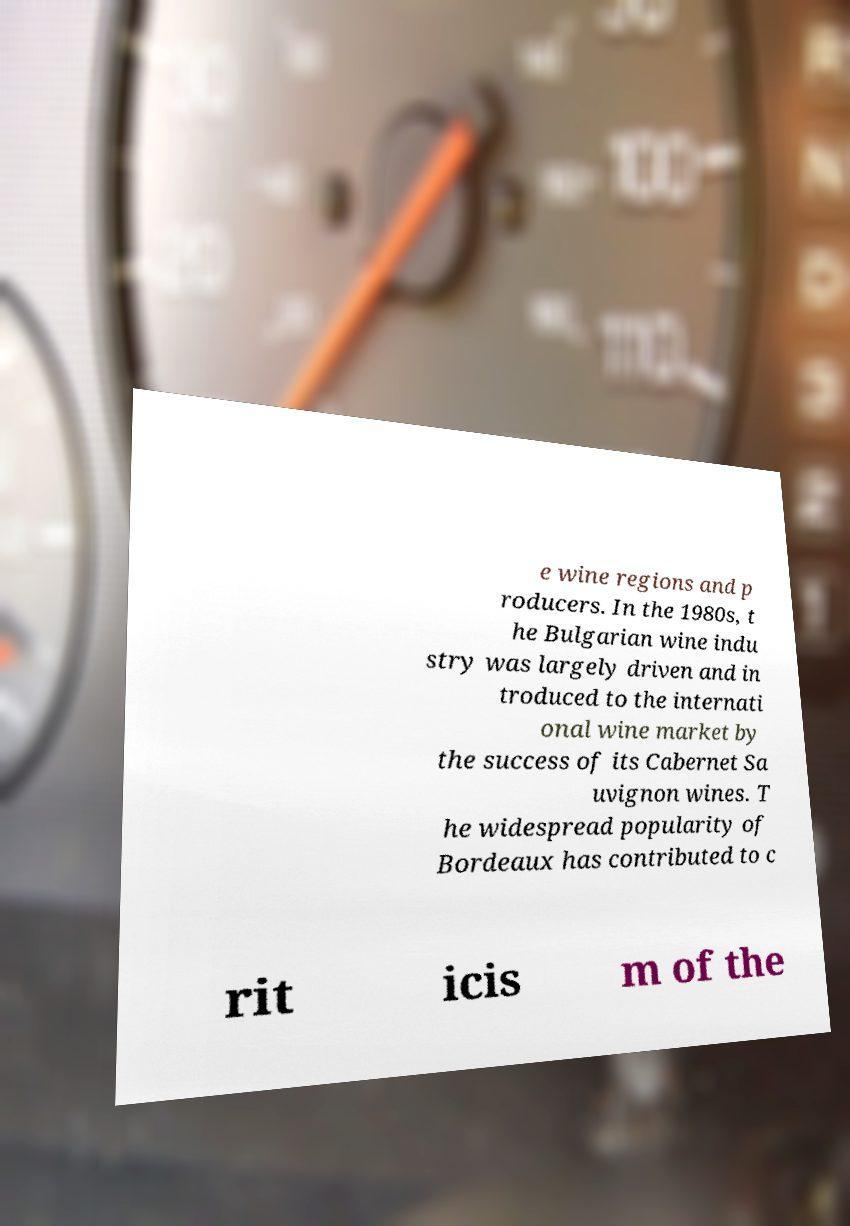Please read and relay the text visible in this image. What does it say? e wine regions and p roducers. In the 1980s, t he Bulgarian wine indu stry was largely driven and in troduced to the internati onal wine market by the success of its Cabernet Sa uvignon wines. T he widespread popularity of Bordeaux has contributed to c rit icis m of the 